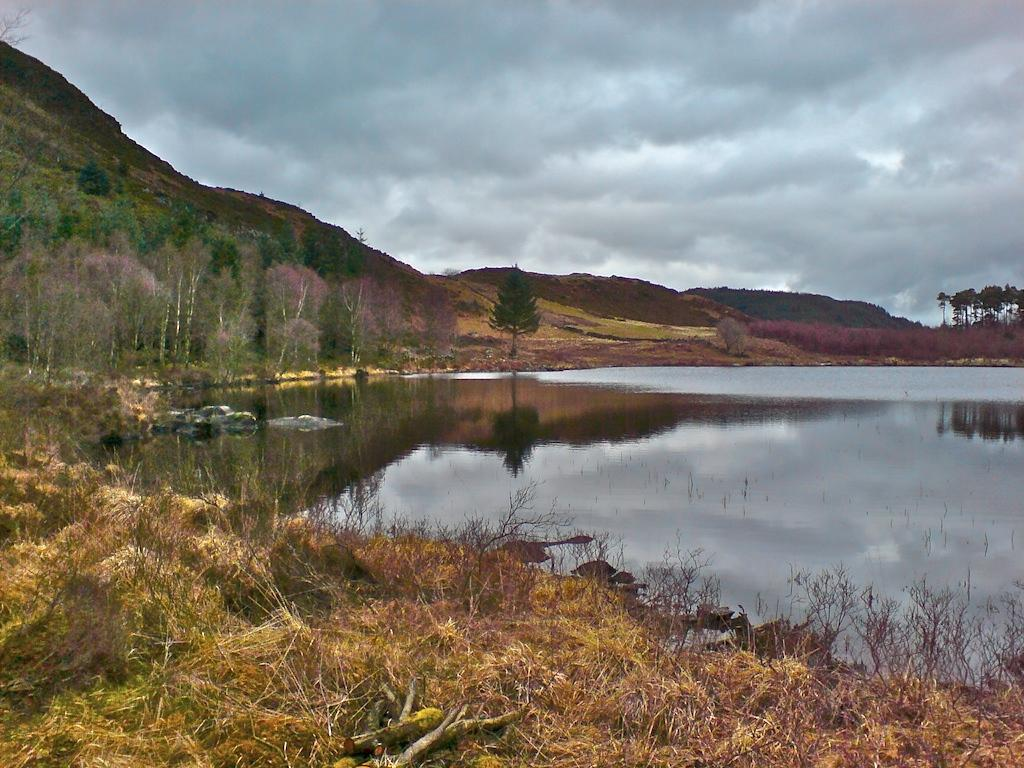What can be seen in the right corner of the image? There is water in the right corner of the image. What is present in the left corner of the image? There is grass in the left corner of the image. What type of vegetation can be seen in the background of the image? There are trees in the background of the image. What geographical feature is visible in the background of the image? There are mountains in the background of the image. What type of creature is interacting with the water in the image? There is no creature present in the image; it only features water, grass, trees, and mountains. What type of system is responsible for the water flow in the image? There is no system responsible for the water flow in the image, as it is a still image and not a video or animation. 